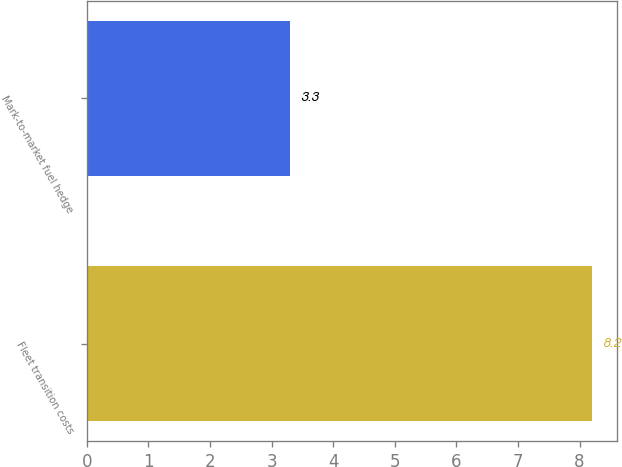<chart> <loc_0><loc_0><loc_500><loc_500><bar_chart><fcel>Fleet transition costs<fcel>Mark-to-market fuel hedge<nl><fcel>8.2<fcel>3.3<nl></chart> 